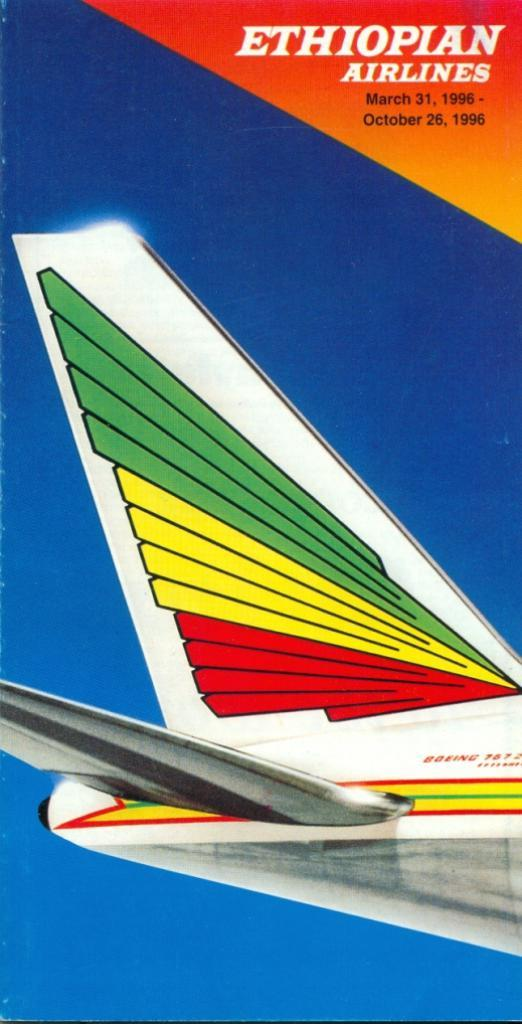Provide a one-sentence caption for the provided image. A brochure for Ethiopian Airlines March - October of 1996. 